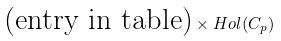Convert formula to latex. <formula><loc_0><loc_0><loc_500><loc_500>\text {(entry in table)} \times H o l ( C _ { p } )</formula> 